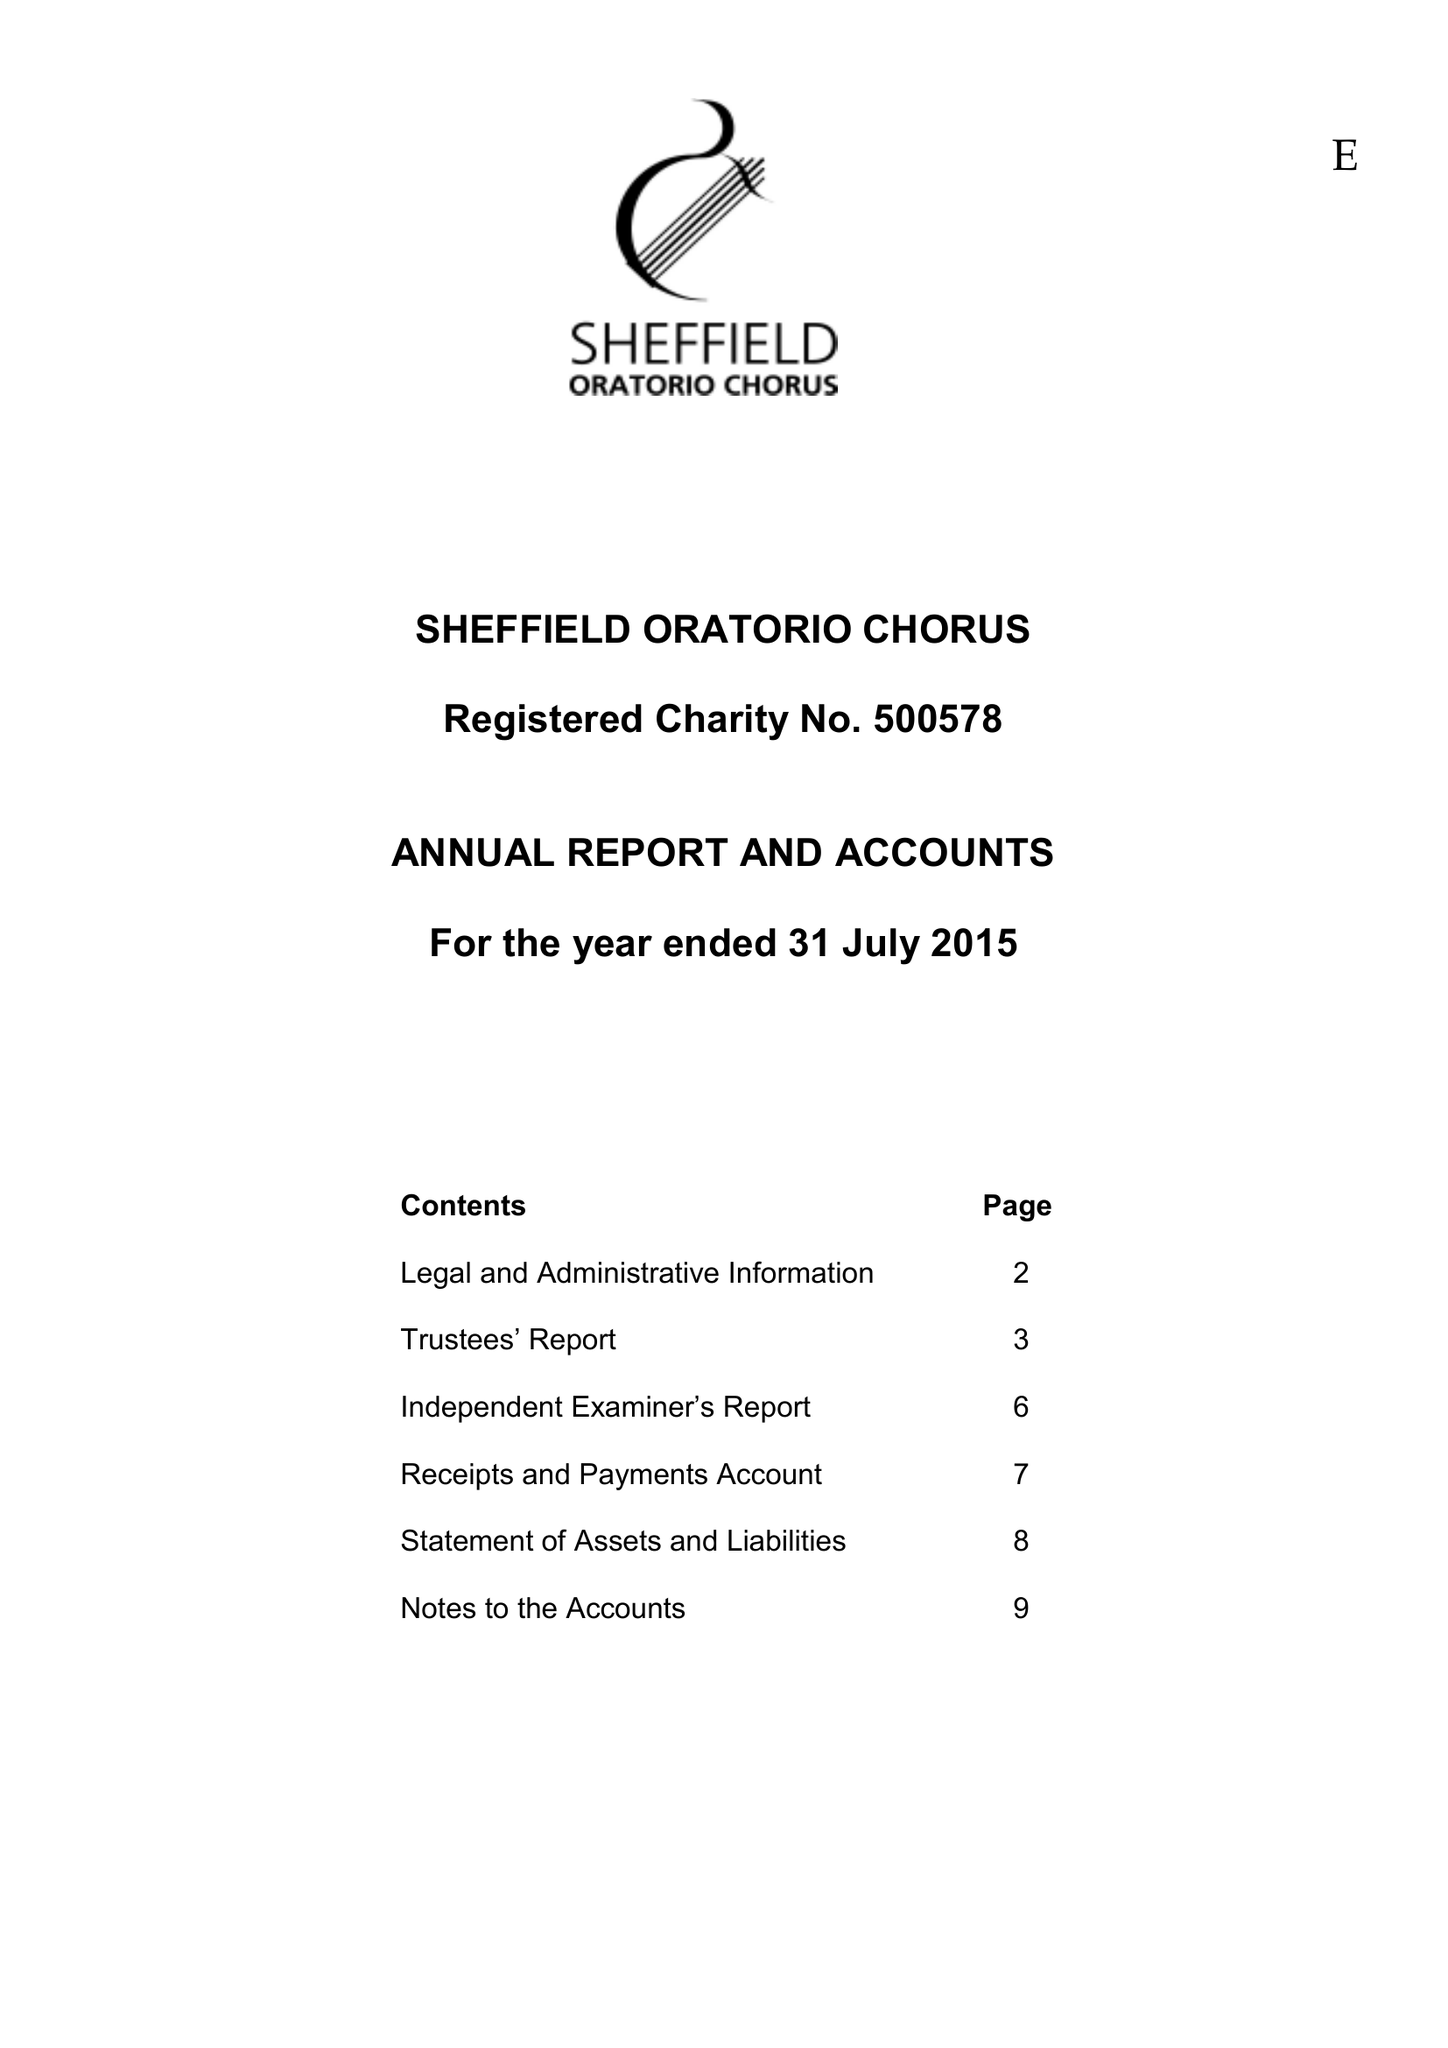What is the value for the report_date?
Answer the question using a single word or phrase. 2015-07-31 